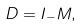Convert formula to latex. <formula><loc_0><loc_0><loc_500><loc_500>D = I _ { - } M ,</formula> 